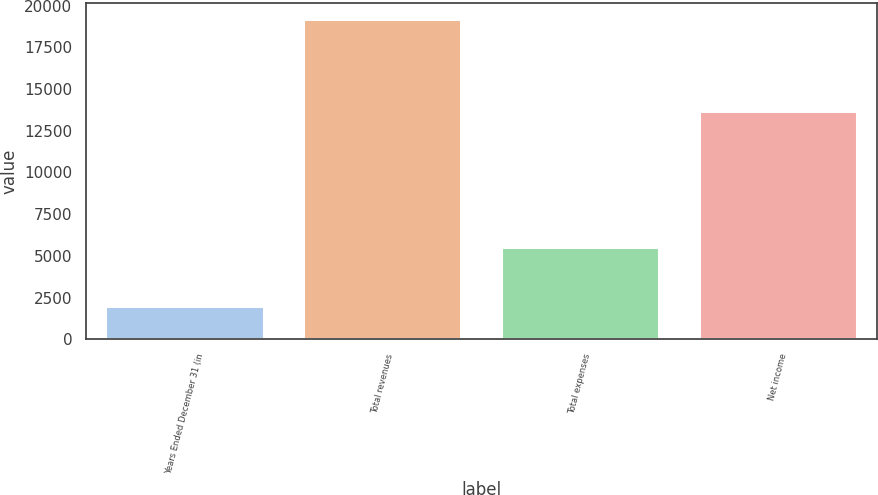Convert chart to OTSL. <chart><loc_0><loc_0><loc_500><loc_500><bar_chart><fcel>Years Ended December 31 (in<fcel>Total revenues<fcel>Total expenses<fcel>Net income<nl><fcel>2013<fcel>19181<fcel>5515<fcel>13666<nl></chart> 